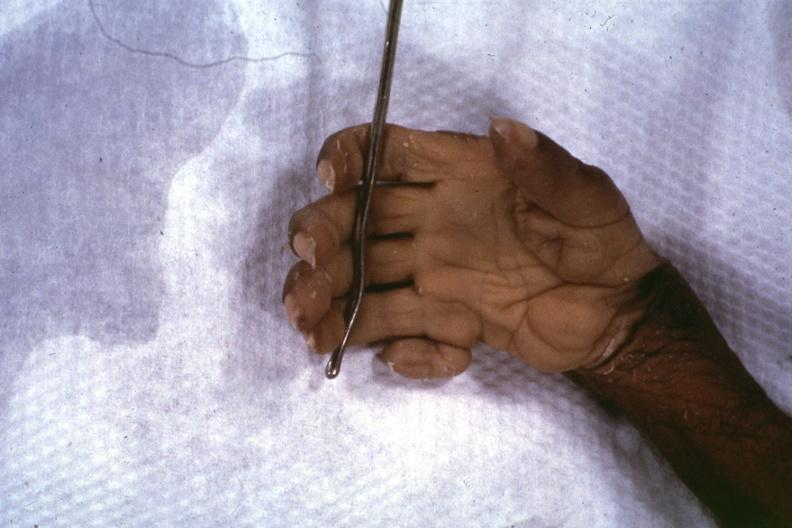what is present?
Answer the question using a single word or phrase. No 